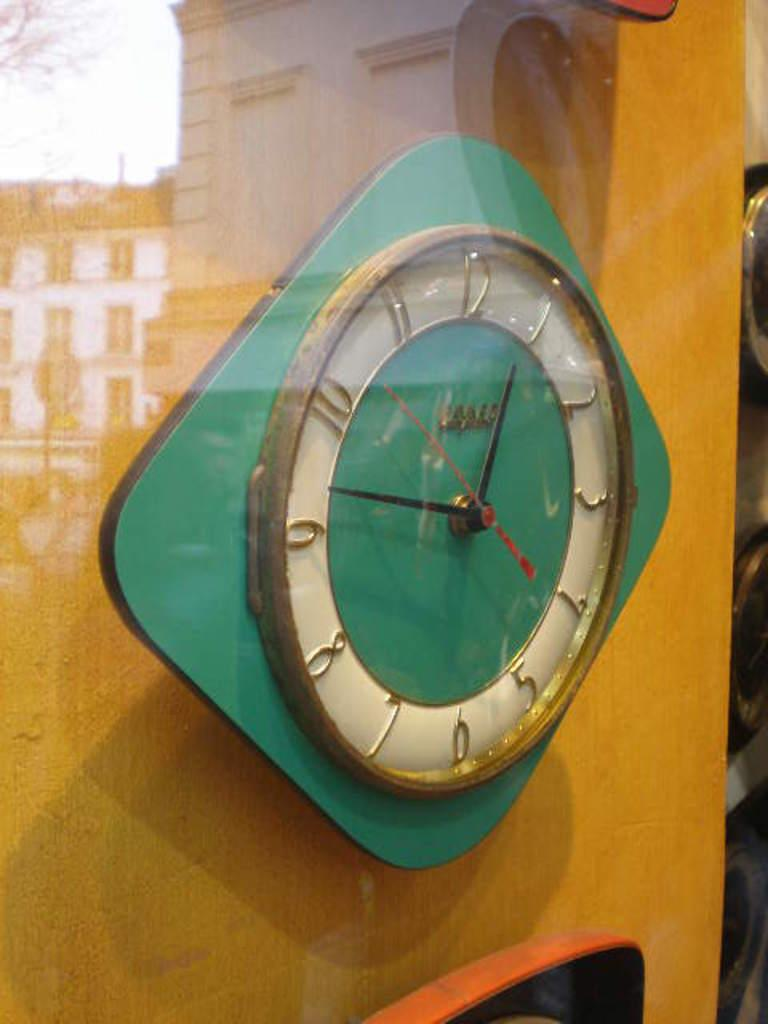<image>
Create a compact narrative representing the image presented. A green clock has the number 12 at the top of the dial. 